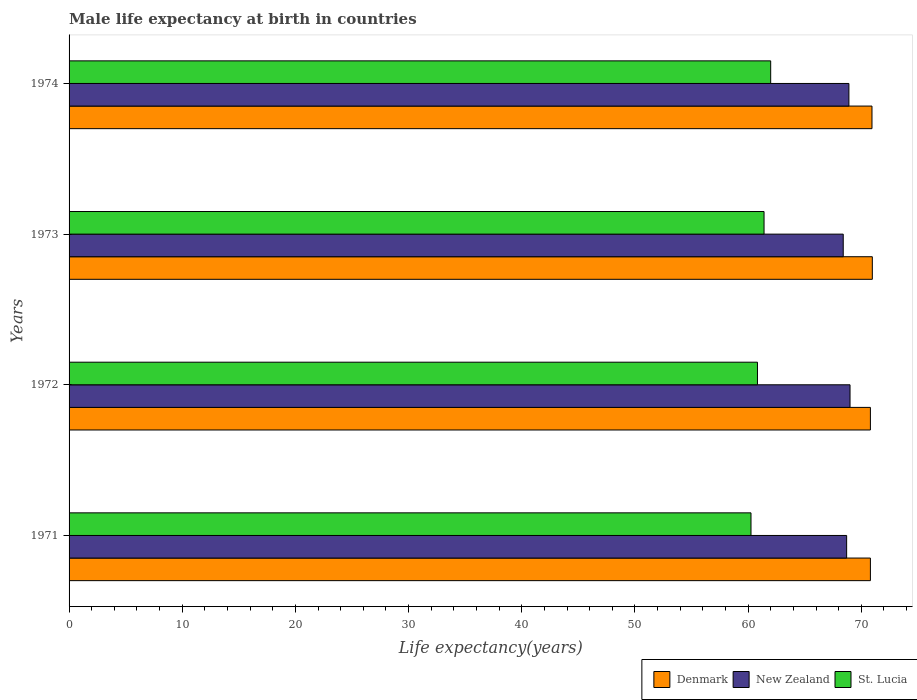How many different coloured bars are there?
Keep it short and to the point. 3. How many groups of bars are there?
Your response must be concise. 4. Are the number of bars on each tick of the Y-axis equal?
Offer a terse response. Yes. How many bars are there on the 1st tick from the bottom?
Provide a succinct answer. 3. What is the label of the 3rd group of bars from the top?
Your response must be concise. 1972. In how many cases, is the number of bars for a given year not equal to the number of legend labels?
Make the answer very short. 0. What is the male life expectancy at birth in St. Lucia in 1972?
Offer a very short reply. 60.82. Across all years, what is the maximum male life expectancy at birth in St. Lucia?
Keep it short and to the point. 61.99. Across all years, what is the minimum male life expectancy at birth in St. Lucia?
Provide a short and direct response. 60.25. What is the total male life expectancy at birth in Denmark in the graph?
Give a very brief answer. 283.51. What is the difference between the male life expectancy at birth in St. Lucia in 1971 and that in 1973?
Your answer should be compact. -1.15. What is the difference between the male life expectancy at birth in Denmark in 1971 and the male life expectancy at birth in New Zealand in 1973?
Keep it short and to the point. 2.4. What is the average male life expectancy at birth in Denmark per year?
Your answer should be compact. 70.88. In the year 1973, what is the difference between the male life expectancy at birth in St. Lucia and male life expectancy at birth in Denmark?
Provide a short and direct response. -9.57. What is the ratio of the male life expectancy at birth in New Zealand in 1973 to that in 1974?
Offer a very short reply. 0.99. What is the difference between the highest and the second highest male life expectancy at birth in St. Lucia?
Offer a very short reply. 0.59. What is the difference between the highest and the lowest male life expectancy at birth in Denmark?
Keep it short and to the point. 0.17. What does the 3rd bar from the bottom in 1971 represents?
Your response must be concise. St. Lucia. How many bars are there?
Offer a very short reply. 12. Are all the bars in the graph horizontal?
Offer a terse response. Yes. What is the difference between two consecutive major ticks on the X-axis?
Your response must be concise. 10. Does the graph contain grids?
Provide a succinct answer. No. Where does the legend appear in the graph?
Your answer should be compact. Bottom right. How many legend labels are there?
Make the answer very short. 3. How are the legend labels stacked?
Ensure brevity in your answer.  Horizontal. What is the title of the graph?
Give a very brief answer. Male life expectancy at birth in countries. Does "San Marino" appear as one of the legend labels in the graph?
Offer a very short reply. No. What is the label or title of the X-axis?
Your answer should be compact. Life expectancy(years). What is the label or title of the Y-axis?
Your answer should be compact. Years. What is the Life expectancy(years) in Denmark in 1971?
Keep it short and to the point. 70.8. What is the Life expectancy(years) of New Zealand in 1971?
Your answer should be very brief. 68.7. What is the Life expectancy(years) in St. Lucia in 1971?
Offer a terse response. 60.25. What is the Life expectancy(years) in Denmark in 1972?
Keep it short and to the point. 70.8. What is the Life expectancy(years) of New Zealand in 1972?
Keep it short and to the point. 69. What is the Life expectancy(years) in St. Lucia in 1972?
Your answer should be very brief. 60.82. What is the Life expectancy(years) in Denmark in 1973?
Offer a terse response. 70.97. What is the Life expectancy(years) in New Zealand in 1973?
Keep it short and to the point. 68.4. What is the Life expectancy(years) in St. Lucia in 1973?
Ensure brevity in your answer.  61.4. What is the Life expectancy(years) of Denmark in 1974?
Your answer should be compact. 70.94. What is the Life expectancy(years) in New Zealand in 1974?
Your answer should be compact. 68.9. What is the Life expectancy(years) in St. Lucia in 1974?
Ensure brevity in your answer.  61.99. Across all years, what is the maximum Life expectancy(years) of Denmark?
Offer a terse response. 70.97. Across all years, what is the maximum Life expectancy(years) in St. Lucia?
Make the answer very short. 61.99. Across all years, what is the minimum Life expectancy(years) of Denmark?
Your answer should be very brief. 70.8. Across all years, what is the minimum Life expectancy(years) of New Zealand?
Offer a terse response. 68.4. Across all years, what is the minimum Life expectancy(years) of St. Lucia?
Your response must be concise. 60.25. What is the total Life expectancy(years) in Denmark in the graph?
Provide a short and direct response. 283.51. What is the total Life expectancy(years) of New Zealand in the graph?
Keep it short and to the point. 275. What is the total Life expectancy(years) in St. Lucia in the graph?
Your answer should be very brief. 244.46. What is the difference between the Life expectancy(years) in St. Lucia in 1971 and that in 1972?
Ensure brevity in your answer.  -0.57. What is the difference between the Life expectancy(years) in Denmark in 1971 and that in 1973?
Make the answer very short. -0.17. What is the difference between the Life expectancy(years) of St. Lucia in 1971 and that in 1973?
Offer a very short reply. -1.15. What is the difference between the Life expectancy(years) in Denmark in 1971 and that in 1974?
Give a very brief answer. -0.14. What is the difference between the Life expectancy(years) of St. Lucia in 1971 and that in 1974?
Your answer should be very brief. -1.74. What is the difference between the Life expectancy(years) in Denmark in 1972 and that in 1973?
Provide a short and direct response. -0.17. What is the difference between the Life expectancy(years) of New Zealand in 1972 and that in 1973?
Make the answer very short. 0.6. What is the difference between the Life expectancy(years) of St. Lucia in 1972 and that in 1973?
Ensure brevity in your answer.  -0.58. What is the difference between the Life expectancy(years) in Denmark in 1972 and that in 1974?
Ensure brevity in your answer.  -0.14. What is the difference between the Life expectancy(years) of New Zealand in 1972 and that in 1974?
Provide a succinct answer. 0.1. What is the difference between the Life expectancy(years) in St. Lucia in 1972 and that in 1974?
Your response must be concise. -1.17. What is the difference between the Life expectancy(years) in New Zealand in 1973 and that in 1974?
Your answer should be very brief. -0.5. What is the difference between the Life expectancy(years) in St. Lucia in 1973 and that in 1974?
Offer a terse response. -0.59. What is the difference between the Life expectancy(years) in Denmark in 1971 and the Life expectancy(years) in St. Lucia in 1972?
Your response must be concise. 9.98. What is the difference between the Life expectancy(years) of New Zealand in 1971 and the Life expectancy(years) of St. Lucia in 1972?
Offer a terse response. 7.88. What is the difference between the Life expectancy(years) in Denmark in 1971 and the Life expectancy(years) in St. Lucia in 1973?
Your response must be concise. 9.4. What is the difference between the Life expectancy(years) of New Zealand in 1971 and the Life expectancy(years) of St. Lucia in 1973?
Offer a very short reply. 7.3. What is the difference between the Life expectancy(years) in Denmark in 1971 and the Life expectancy(years) in St. Lucia in 1974?
Your response must be concise. 8.81. What is the difference between the Life expectancy(years) in New Zealand in 1971 and the Life expectancy(years) in St. Lucia in 1974?
Your answer should be compact. 6.71. What is the difference between the Life expectancy(years) in Denmark in 1972 and the Life expectancy(years) in New Zealand in 1973?
Ensure brevity in your answer.  2.4. What is the difference between the Life expectancy(years) in Denmark in 1972 and the Life expectancy(years) in St. Lucia in 1973?
Offer a terse response. 9.4. What is the difference between the Life expectancy(years) in New Zealand in 1972 and the Life expectancy(years) in St. Lucia in 1973?
Provide a succinct answer. 7.6. What is the difference between the Life expectancy(years) of Denmark in 1972 and the Life expectancy(years) of St. Lucia in 1974?
Your answer should be very brief. 8.81. What is the difference between the Life expectancy(years) of New Zealand in 1972 and the Life expectancy(years) of St. Lucia in 1974?
Provide a succinct answer. 7.01. What is the difference between the Life expectancy(years) in Denmark in 1973 and the Life expectancy(years) in New Zealand in 1974?
Make the answer very short. 2.07. What is the difference between the Life expectancy(years) in Denmark in 1973 and the Life expectancy(years) in St. Lucia in 1974?
Your answer should be very brief. 8.98. What is the difference between the Life expectancy(years) in New Zealand in 1973 and the Life expectancy(years) in St. Lucia in 1974?
Give a very brief answer. 6.41. What is the average Life expectancy(years) in Denmark per year?
Offer a very short reply. 70.88. What is the average Life expectancy(years) in New Zealand per year?
Your response must be concise. 68.75. What is the average Life expectancy(years) of St. Lucia per year?
Your response must be concise. 61.12. In the year 1971, what is the difference between the Life expectancy(years) in Denmark and Life expectancy(years) in New Zealand?
Your response must be concise. 2.1. In the year 1971, what is the difference between the Life expectancy(years) of Denmark and Life expectancy(years) of St. Lucia?
Provide a succinct answer. 10.55. In the year 1971, what is the difference between the Life expectancy(years) in New Zealand and Life expectancy(years) in St. Lucia?
Offer a very short reply. 8.45. In the year 1972, what is the difference between the Life expectancy(years) in Denmark and Life expectancy(years) in St. Lucia?
Make the answer very short. 9.98. In the year 1972, what is the difference between the Life expectancy(years) in New Zealand and Life expectancy(years) in St. Lucia?
Ensure brevity in your answer.  8.18. In the year 1973, what is the difference between the Life expectancy(years) of Denmark and Life expectancy(years) of New Zealand?
Your response must be concise. 2.57. In the year 1973, what is the difference between the Life expectancy(years) in Denmark and Life expectancy(years) in St. Lucia?
Make the answer very short. 9.57. In the year 1973, what is the difference between the Life expectancy(years) of New Zealand and Life expectancy(years) of St. Lucia?
Provide a short and direct response. 7. In the year 1974, what is the difference between the Life expectancy(years) of Denmark and Life expectancy(years) of New Zealand?
Provide a short and direct response. 2.04. In the year 1974, what is the difference between the Life expectancy(years) of Denmark and Life expectancy(years) of St. Lucia?
Ensure brevity in your answer.  8.95. In the year 1974, what is the difference between the Life expectancy(years) of New Zealand and Life expectancy(years) of St. Lucia?
Offer a very short reply. 6.91. What is the ratio of the Life expectancy(years) in Denmark in 1971 to that in 1972?
Offer a very short reply. 1. What is the ratio of the Life expectancy(years) of St. Lucia in 1971 to that in 1972?
Give a very brief answer. 0.99. What is the ratio of the Life expectancy(years) of Denmark in 1971 to that in 1973?
Your answer should be compact. 1. What is the ratio of the Life expectancy(years) in St. Lucia in 1971 to that in 1973?
Your answer should be very brief. 0.98. What is the ratio of the Life expectancy(years) in New Zealand in 1971 to that in 1974?
Offer a very short reply. 1. What is the ratio of the Life expectancy(years) in St. Lucia in 1971 to that in 1974?
Give a very brief answer. 0.97. What is the ratio of the Life expectancy(years) of New Zealand in 1972 to that in 1973?
Your answer should be very brief. 1.01. What is the ratio of the Life expectancy(years) of St. Lucia in 1972 to that in 1973?
Ensure brevity in your answer.  0.99. What is the ratio of the Life expectancy(years) in St. Lucia in 1972 to that in 1974?
Your answer should be compact. 0.98. What is the ratio of the Life expectancy(years) in Denmark in 1973 to that in 1974?
Give a very brief answer. 1. What is the difference between the highest and the second highest Life expectancy(years) in St. Lucia?
Your answer should be very brief. 0.59. What is the difference between the highest and the lowest Life expectancy(years) in Denmark?
Offer a very short reply. 0.17. What is the difference between the highest and the lowest Life expectancy(years) in New Zealand?
Provide a succinct answer. 0.6. What is the difference between the highest and the lowest Life expectancy(years) in St. Lucia?
Ensure brevity in your answer.  1.74. 